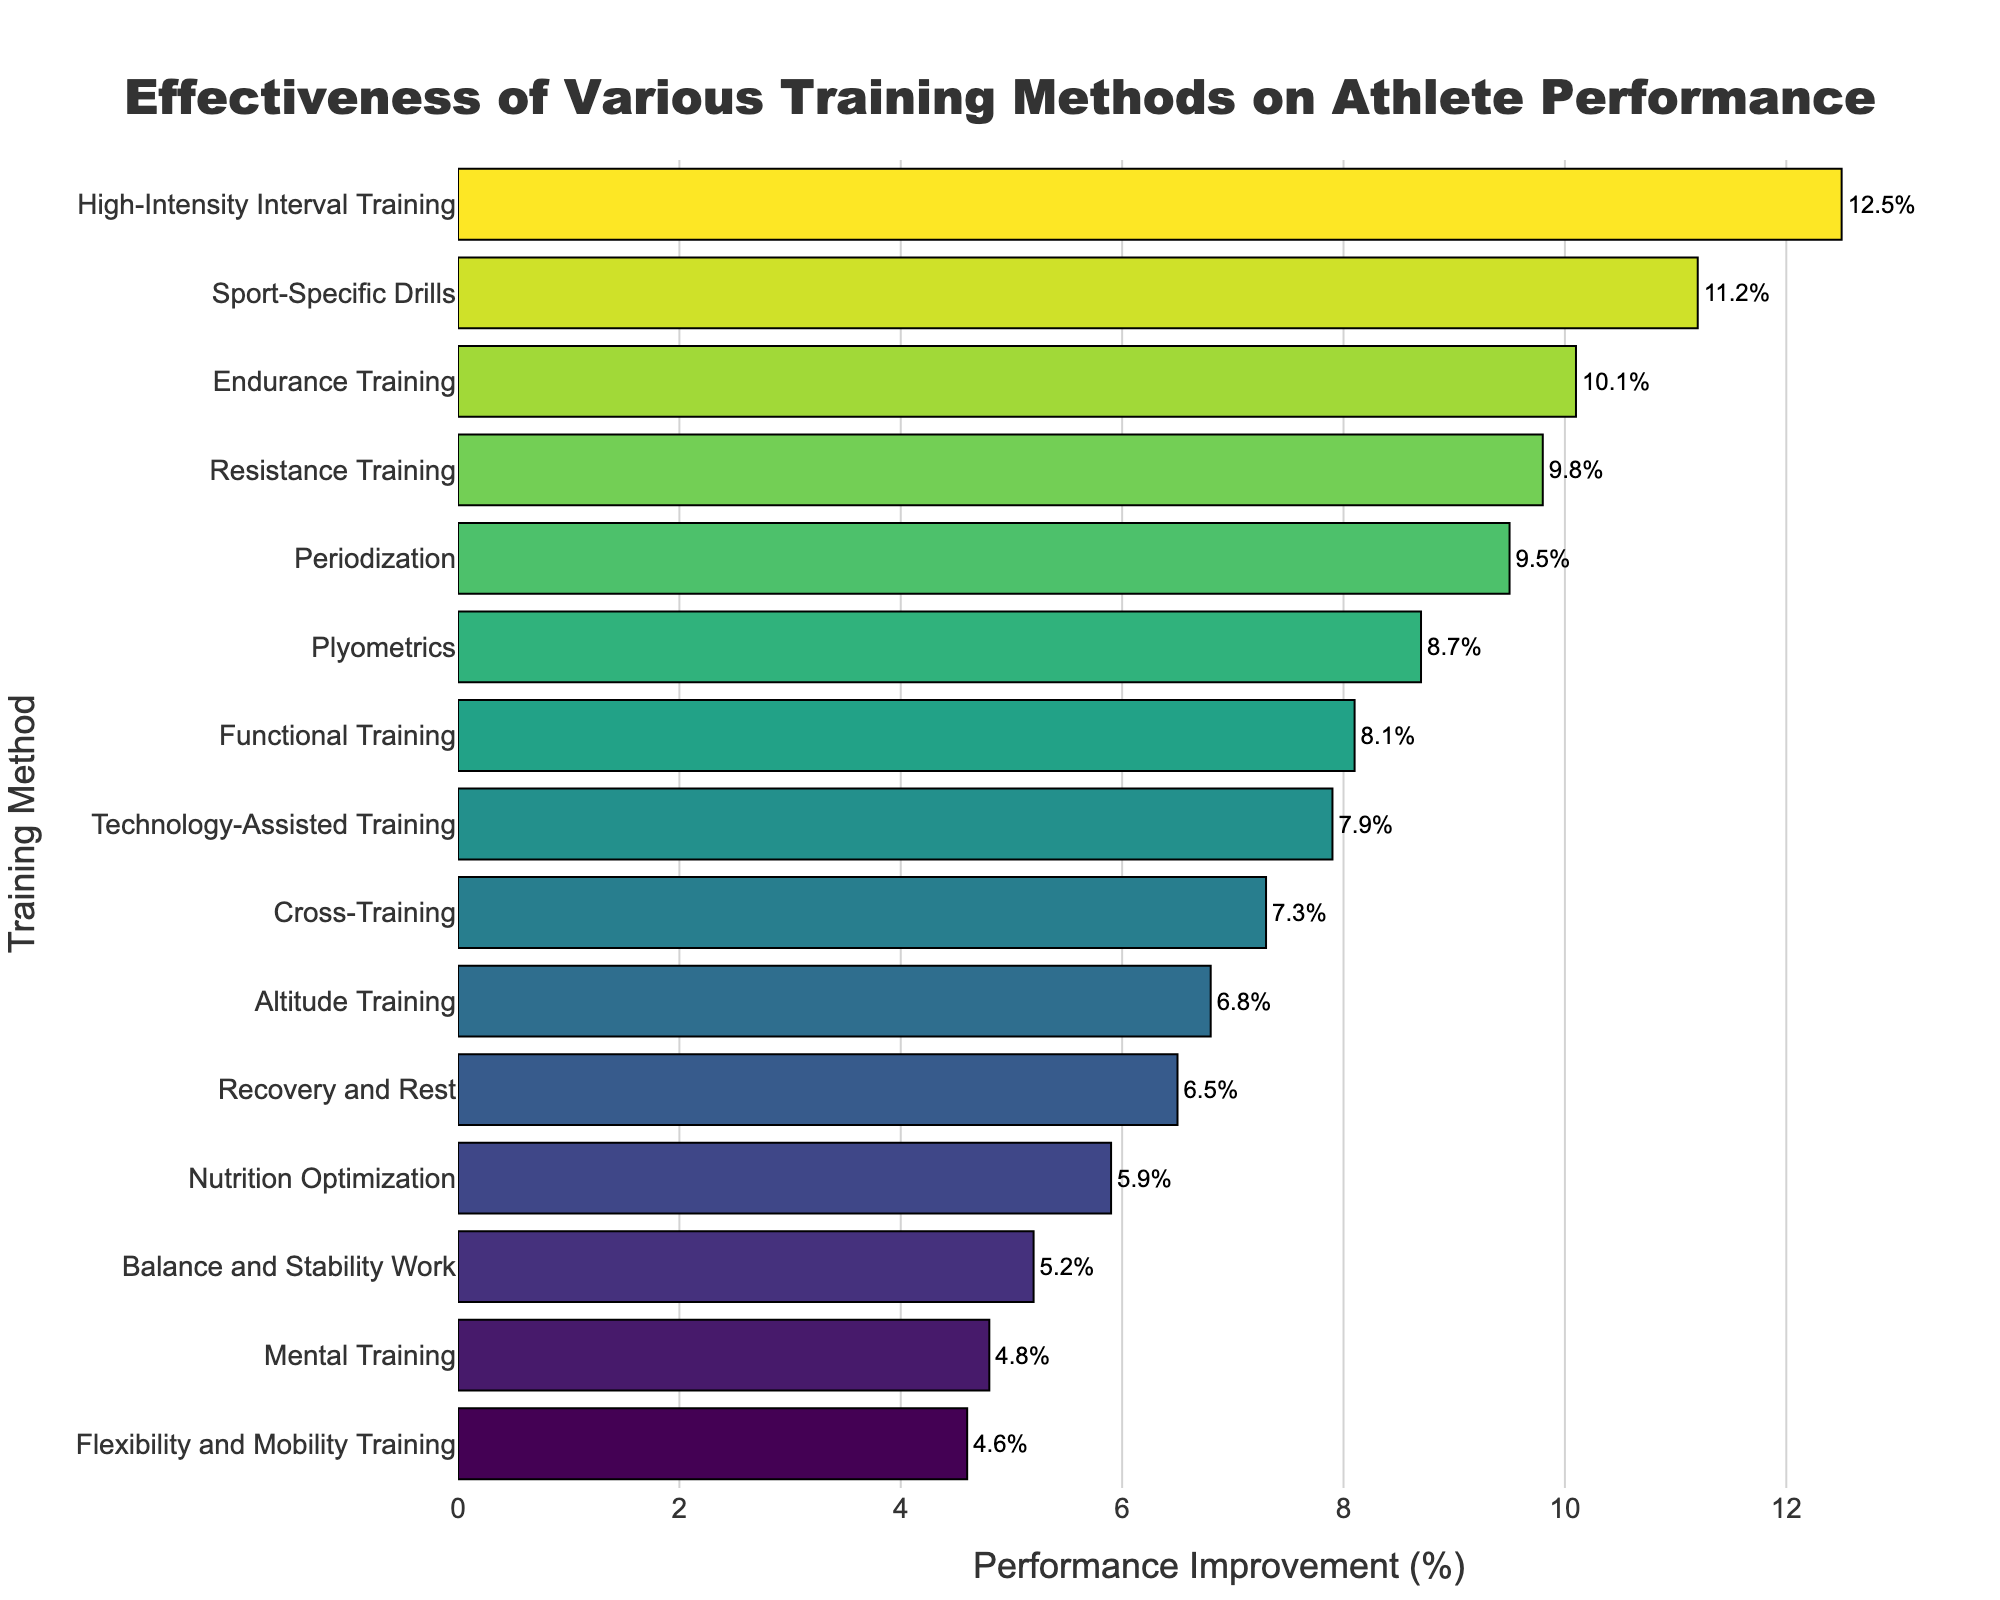Which training method has the highest performance improvement? By looking at the bar chart, identify the bar with the greatest length, corresponding to the highest performance improvement percentage.
Answer: High-Intensity Interval Training Which training method has the lowest performance improvement? Find the shortest bar in the chart, which represents the lowest performance improvement percentage.
Answer: Mental Training What is the difference in performance improvement between High-Intensity Interval Training and Mental Training? Subtract the performance improvement percentage of Mental Training from that of High-Intensity Interval Training. (12.5% - 4.8%)
Answer: 7.7% Which training method shows a performance improvement greater than 10% but less than 13%? Identify the bars within the 10%-13% range by their lengths and the annotated percentages.
Answer: High-Intensity Interval Training, Sport-Specific Drills, Endurance Training How many training methods have a performance improvement of more than 9%? Count the bars with performance improvement percentages greater than 9%.
Answer: 6 Average the performance improvements of Endurance Training and Resistance Training. Add the performance improvement percentages of Endurance Training and Resistance Training, then divide by 2. ((10.1% + 9.8%) / 2)
Answer: 9.95% Which has a higher performance improvement: Cross-Training or Functional Training? Compare the lengths of the bars representing Cross-Training and Functional Training.
Answer: Functional Training Is the performance improvement of Nutrition Optimization less than that of Recovery and Rest? Check the bar lengths for Nutrition Optimization and Recovery and Rest to compare their performance improvements.
Answer: Yes What is the combined performance improvement of Sport-Specific Drills, Periodization, and Technology-Assisted Training? Sum the performance improvement percentages of these three methods. (11.2% + 9.5% + 7.9%)
Answer: 28.6% Which training method has performance improvement closest to the average of all methods? First calculate the average performance improvement of all methods, then find the bar whose value is nearest to this average.
Answer: Technology-Assisted Training 